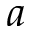Convert formula to latex. <formula><loc_0><loc_0><loc_500><loc_500>a</formula> 